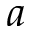Convert formula to latex. <formula><loc_0><loc_0><loc_500><loc_500>a</formula> 